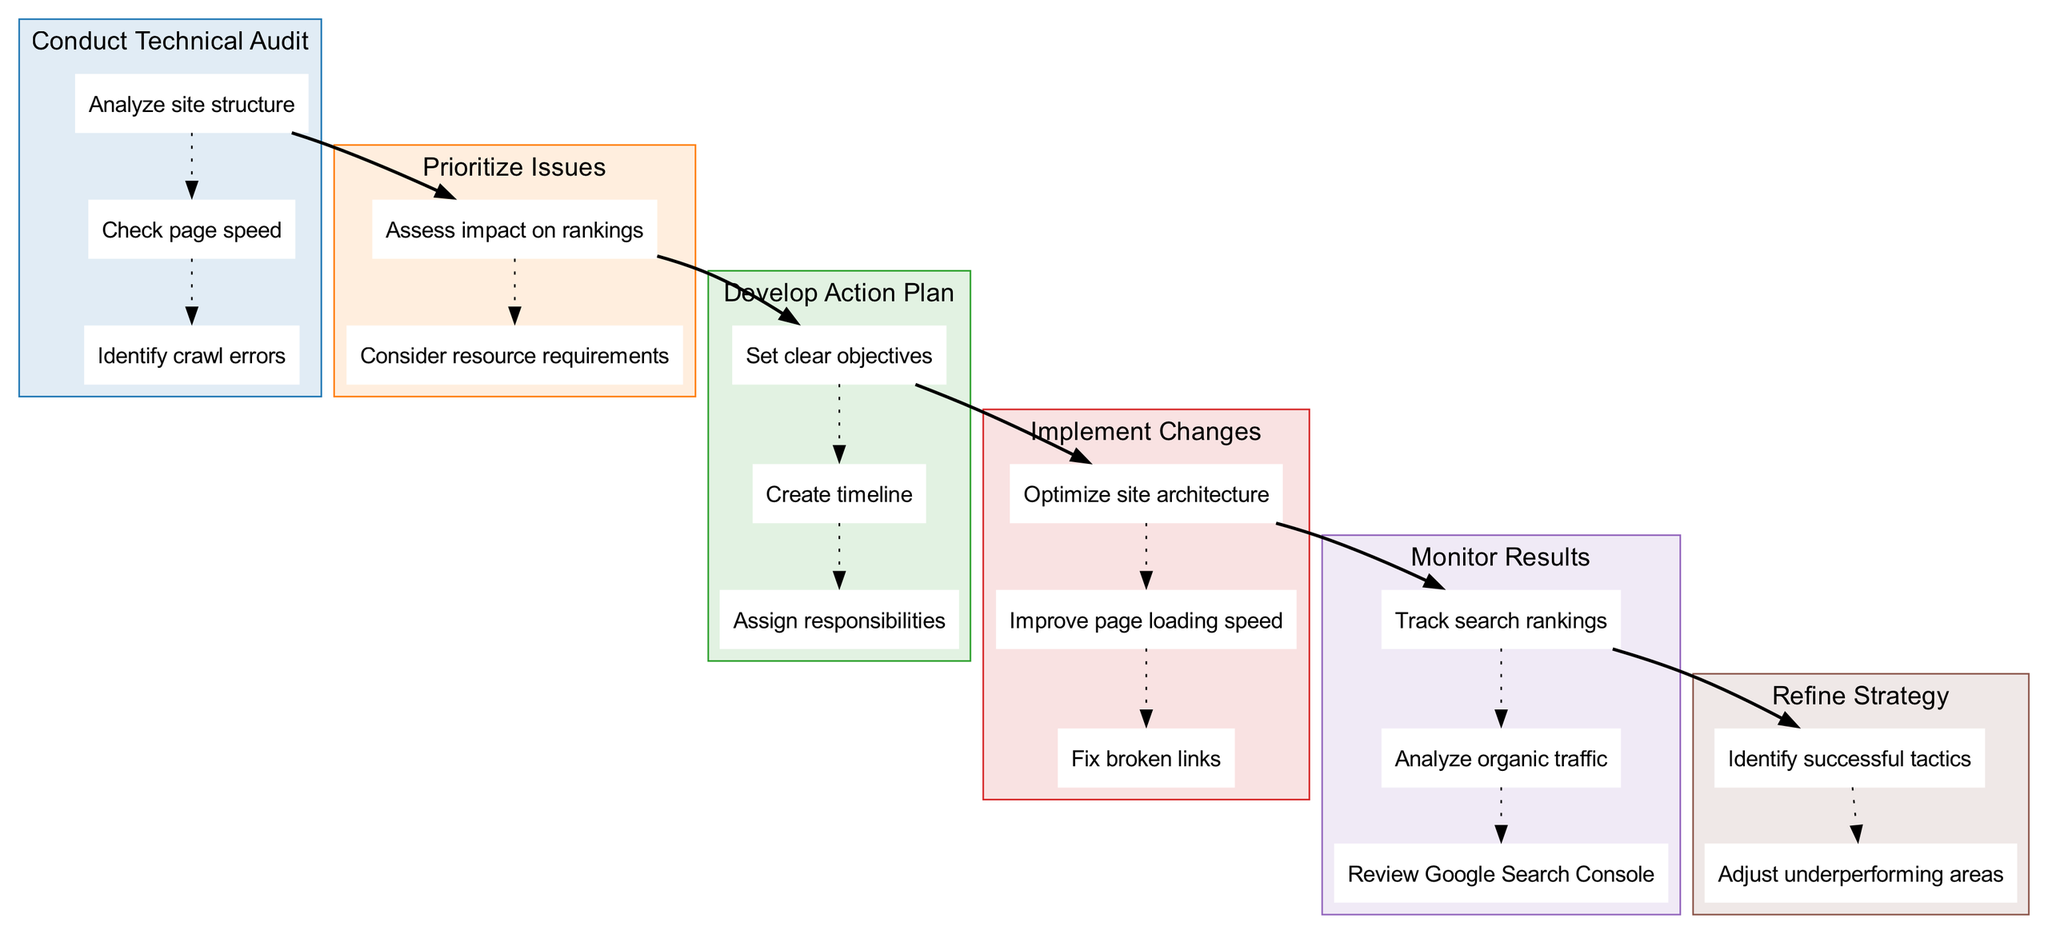What is the first step in the process? The first step listed in the diagram is "Conduct Technical Audit," which is the primary focus of the initial stage of the technical SEO implementation process.
Answer: Conduct Technical Audit How many substeps are there in "Develop Action Plan"? The "Develop Action Plan" step has three substeps: "Set clear objectives," "Create timeline," and "Assign responsibilities." By counting these, we find that there are three substeps.
Answer: Three What do the substeps under "Implement Changes" focus on? The substeps under "Implement Changes" include "Optimize site architecture," "Improve page loading speed," and "Fix broken links." Each of these substeps pertains to the actions taken to address the technical SEO issues.
Answer: Optimize site architecture, Improve page loading speed, Fix broken links What is the relationship between "Prioritize Issues" and "Conduct Technical Audit"? "Prioritize Issues" directly follows after "Conduct Technical Audit," indicating that after completing the audit, the next logical step is to assess and prioritize the identified issues based on the findings of the audit.
Answer: Directly follows Which step involves tracking search rankings? The step that involves tracking search rankings is "Monitor Results," where the focus is on assessing the outcomes of the implemented changes, specifically through ranking metrics.
Answer: Monitor Results What are the last two substeps of "Refine Strategy"? The last two substeps of "Refine Strategy" are "Identify successful tactics" and "Adjust underperforming areas," indicating the continuous improvement approach after monitoring the results.
Answer: Identify successful tactics, Adjust underperforming areas What is the color scheme used for the steps in the diagram? The color scheme consists of six colors: blue, orange, green, red, purple, and brown. Each step in the diagram is highlighted in one of these colors to visually distinguish the sections.
Answer: Blue, orange, green, red, purple, brown How many steps are included in the technical SEO implementation process? There are six key steps included in the technical SEO implementation process, which guide the workflow from the initial audit to the refinement of the strategy.
Answer: Six 